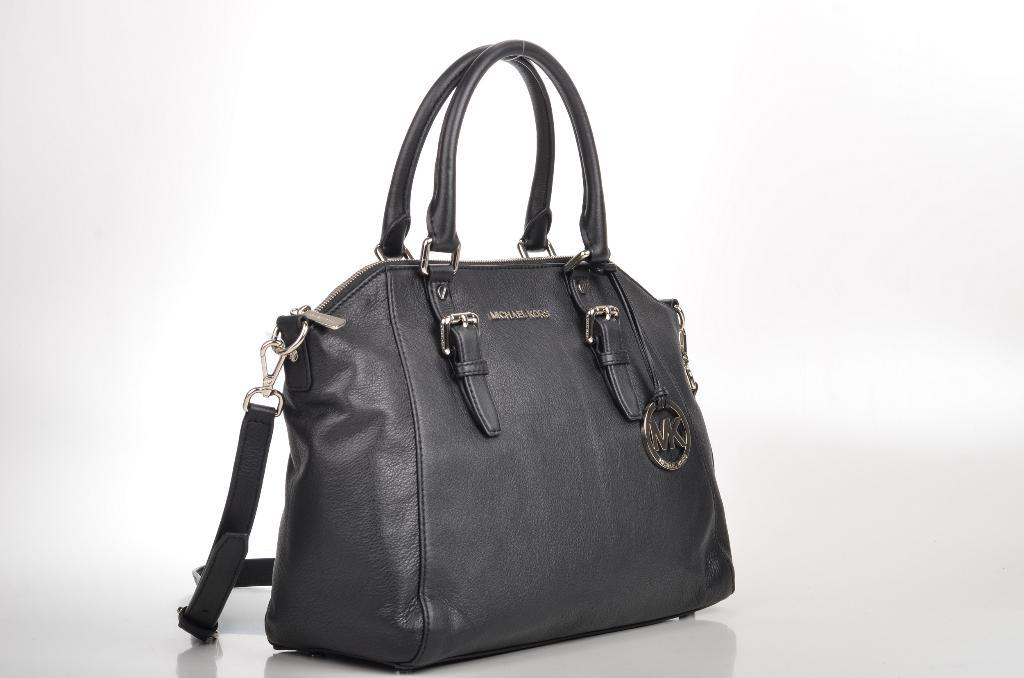What type of accessory is visible in the image? There is a black handbag in the image. What type of star can be heard singing in the image? There is no star or singing present in the image; it only features a black handbag. 